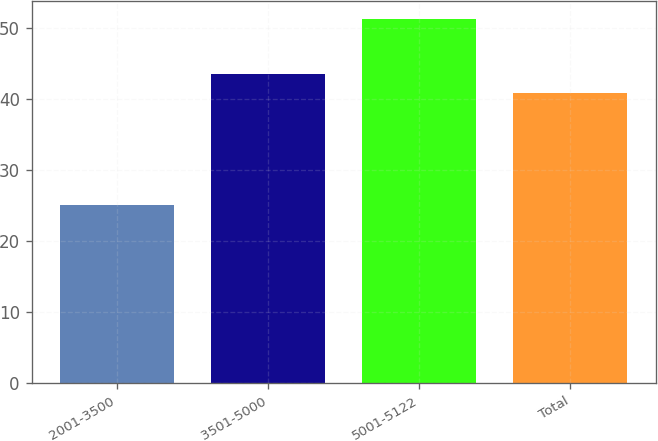Convert chart. <chart><loc_0><loc_0><loc_500><loc_500><bar_chart><fcel>2001-3500<fcel>3501-5000<fcel>5001-5122<fcel>Total<nl><fcel>25.01<fcel>43.4<fcel>51.22<fcel>40.78<nl></chart> 